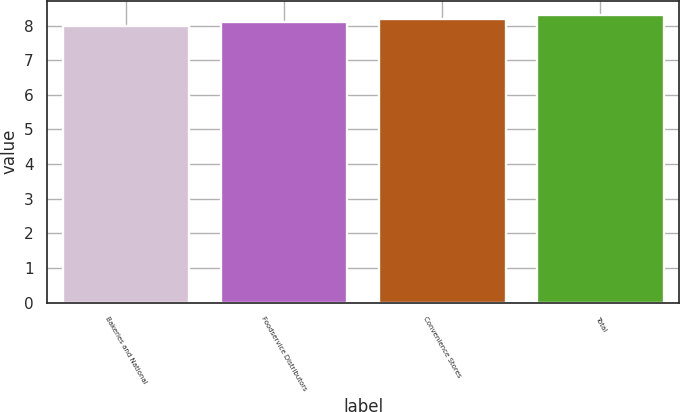<chart> <loc_0><loc_0><loc_500><loc_500><bar_chart><fcel>Bakeries and National<fcel>Foodservice Distributors<fcel>Convenience Stores<fcel>Total<nl><fcel>8<fcel>8.1<fcel>8.2<fcel>8.3<nl></chart> 